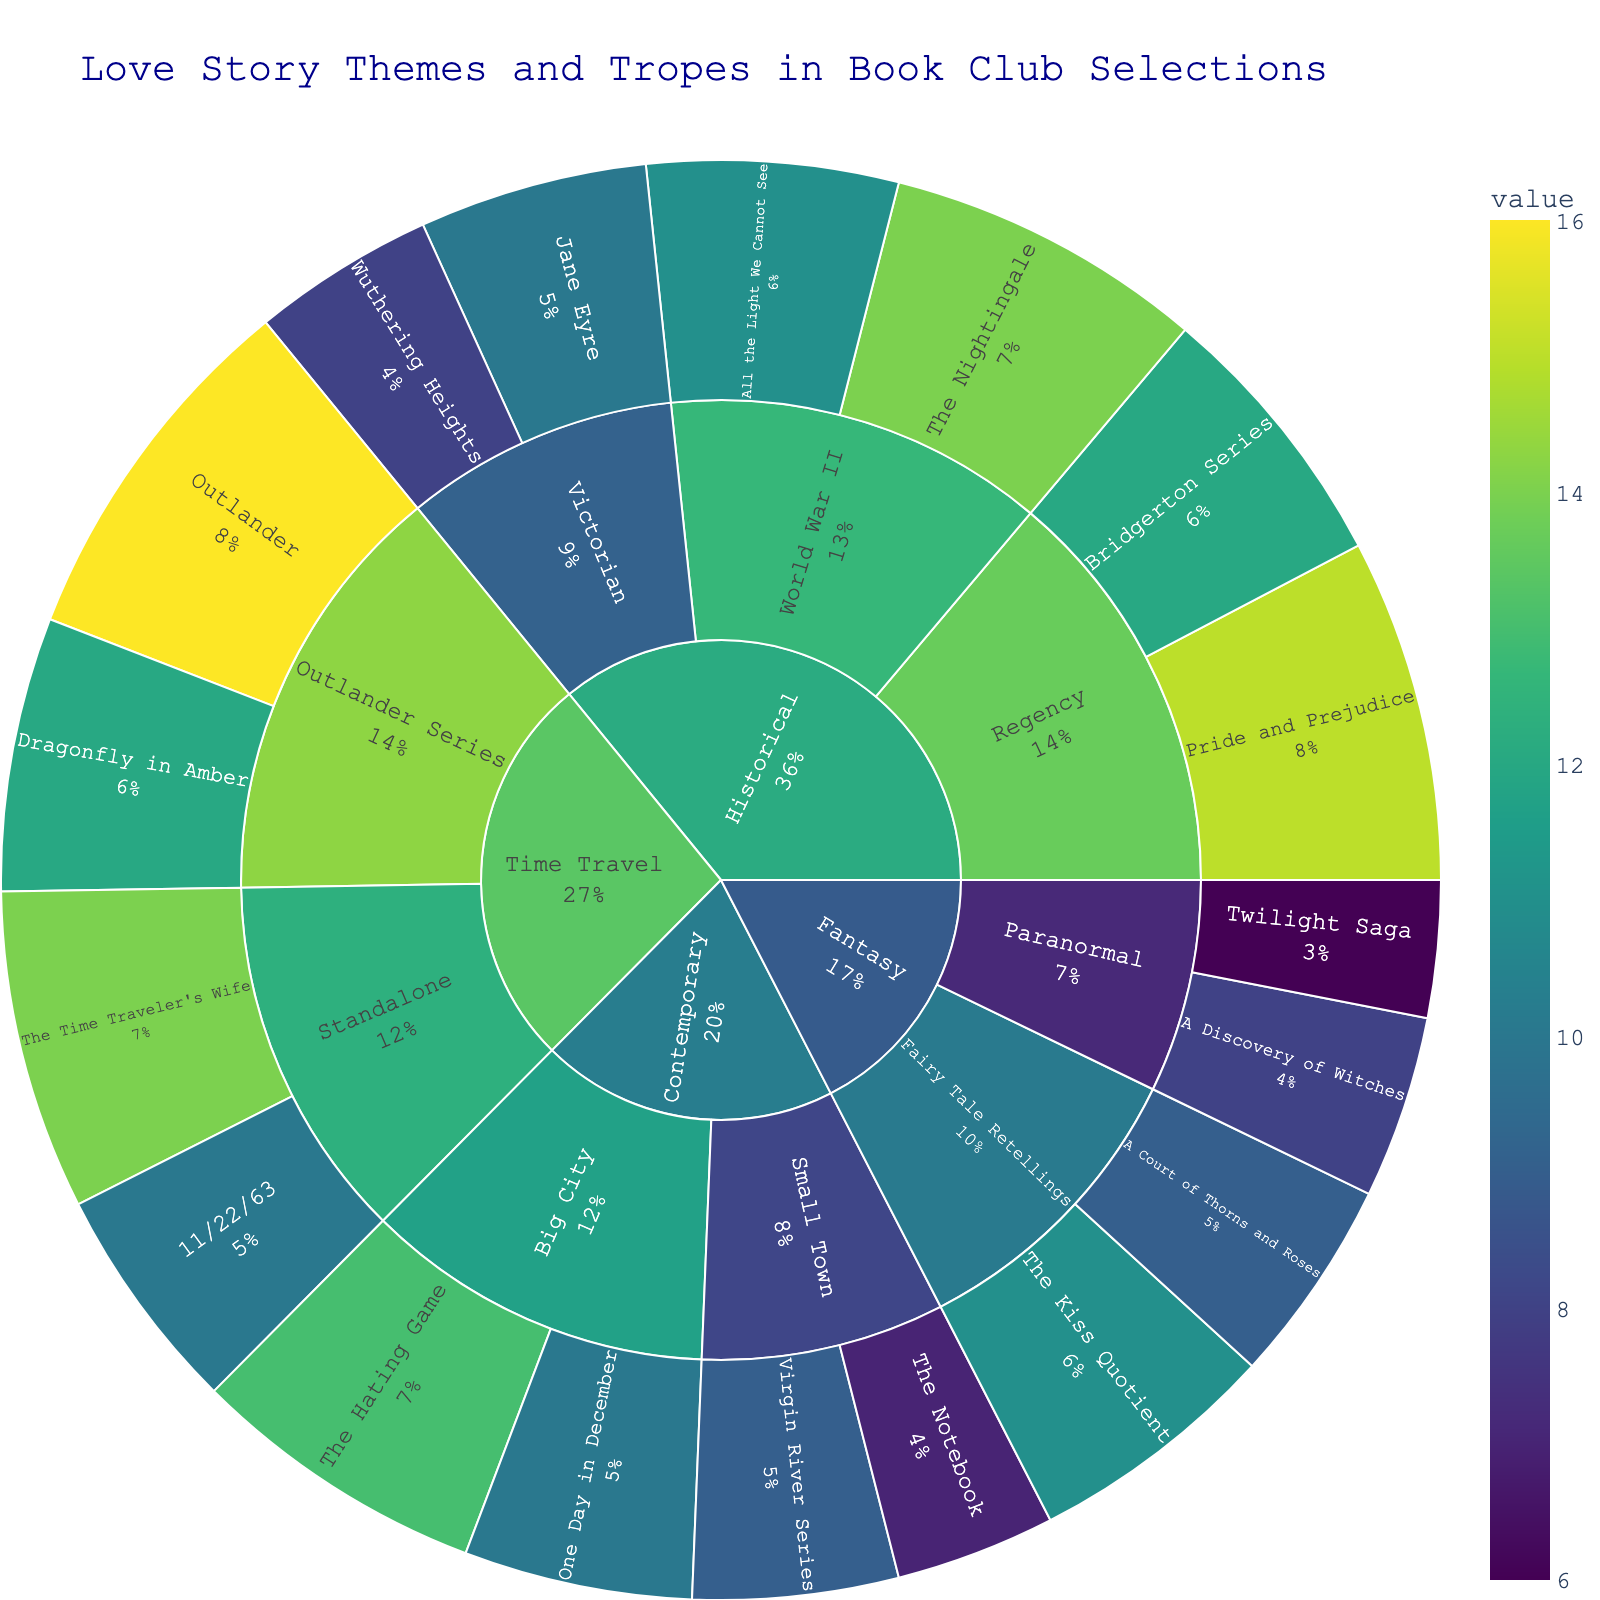What is the title of the figure? The title is usually placed at the top of the figure, and it summarizes the main topic of the plot.
Answer: Love Story Themes and Tropes in Book Club Selections Which subcategory in Historical has the highest value? Look at the Historical category and compare the total values of each subcategory (Regency, Victorian, World War II). Regency has 27, Victorian has 18, and World War II has 25. Hence, Regency is highest.
Answer: Regency What is the total value for subcategory Small Town under Contemporary? Add the values of books falling under the subcategory Small Town in Contemporary: Virgin River Series (9) + The Notebook (7).
Answer: 16 Are there more books in the category Historical or Contemporary? Sum the values of all sub-categories under Historical and compare it with the sum of values under Contemporary. Historical: 15+12+10+8+14+11=70, Contemporary: 9+7+13+10=39. Historical has more books.
Answer: Historical Which book in the Fantasy category has the highest value? Compare the values of all books in the Fantasy category: Twilight Saga (6), A Discovery of Witches (8), The Kiss Quotient (11), A Court of Thorns and Roses (9). The Kiss Quotient has the highest value.
Answer: The Kiss Quotient What percentage of the total do Regency books in Historical contribute? First, find the total value of all books which is 70+39+34+52=195. Then sum the values of Regency books: Pride and Prejudice (15) + Bridgerton Series (12)=27. The percentage is (27/195)*100.
Answer: 13.8% Which has a higher value in Contemporary, Big City or Small Town? Compare the total values of books falling under Big City and Small Town subcategories in Contemporary. Small Town: 9+7=16, Big City: 13+10=23. Big City has a higher value.
Answer: Big City How many total books are there in the Time Travel category? Sum the values of all books under the Time Travel category: Outlander (16), Dragonfly in Amber (12), The Time Traveler's Wife (14), 11/22/63 (10).
Answer: 52 Which book has the highest value across all categories? Identify the book with the maximum value across all categories and subcategories. Outlander has the highest value (16).
Answer: Outlander 